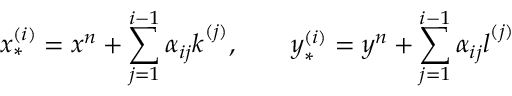<formula> <loc_0><loc_0><loc_500><loc_500>x _ { * } ^ { ( i ) } = x ^ { n } + \sum _ { j = 1 } ^ { i - 1 } \alpha _ { i j } k ^ { ( j ) } , \quad y _ { * } ^ { ( i ) } = y ^ { n } + \sum _ { j = 1 } ^ { i - 1 } \alpha _ { i j } l ^ { ( j ) }</formula> 